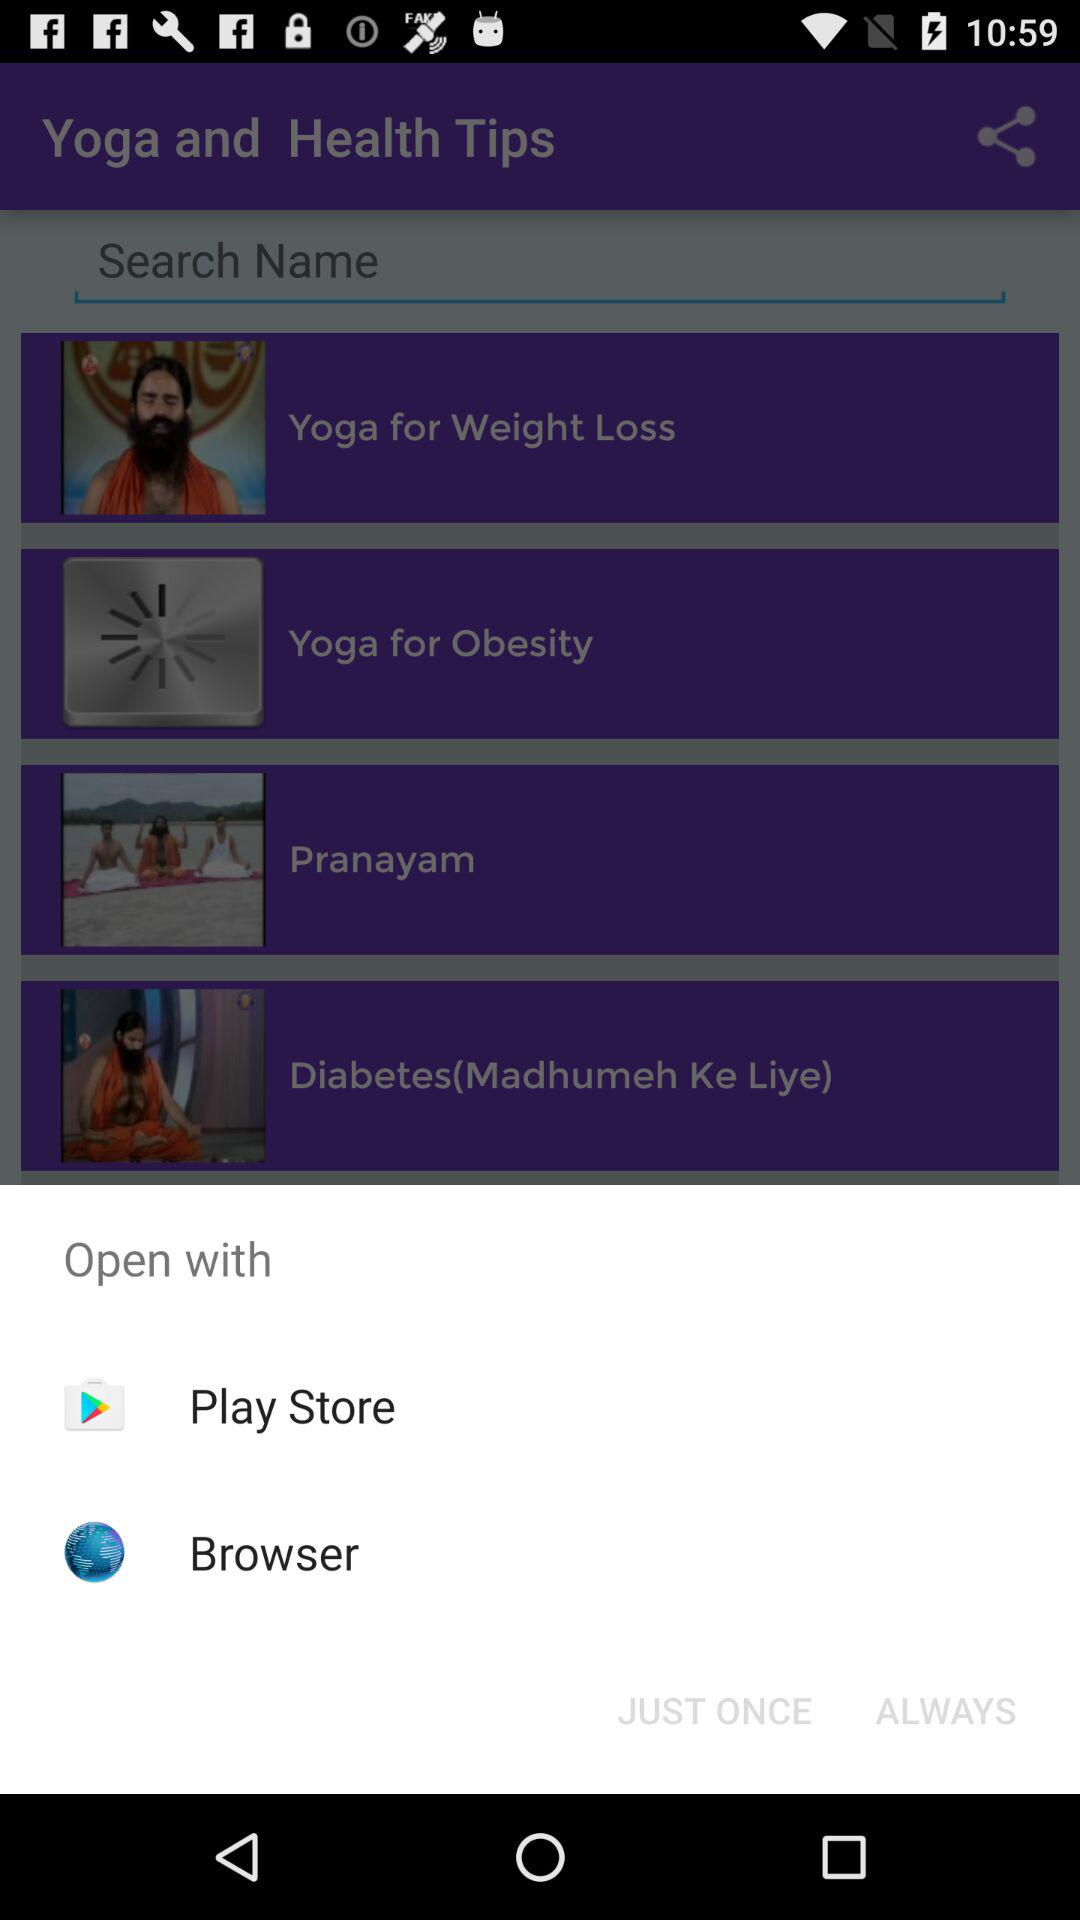What are the options given to open the application? The given options are "Play Store" and "Browser". 